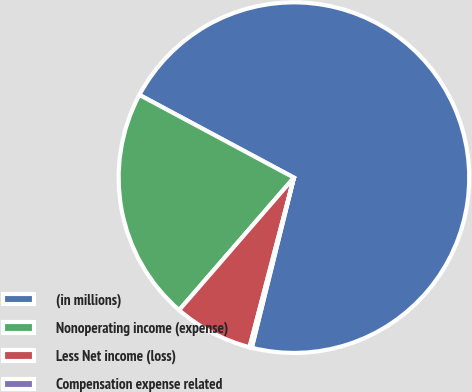<chart> <loc_0><loc_0><loc_500><loc_500><pie_chart><fcel>(in millions)<fcel>Nonoperating income (expense)<fcel>Less Net income (loss)<fcel>Compensation expense related<nl><fcel>71.04%<fcel>21.46%<fcel>7.29%<fcel>0.21%<nl></chart> 